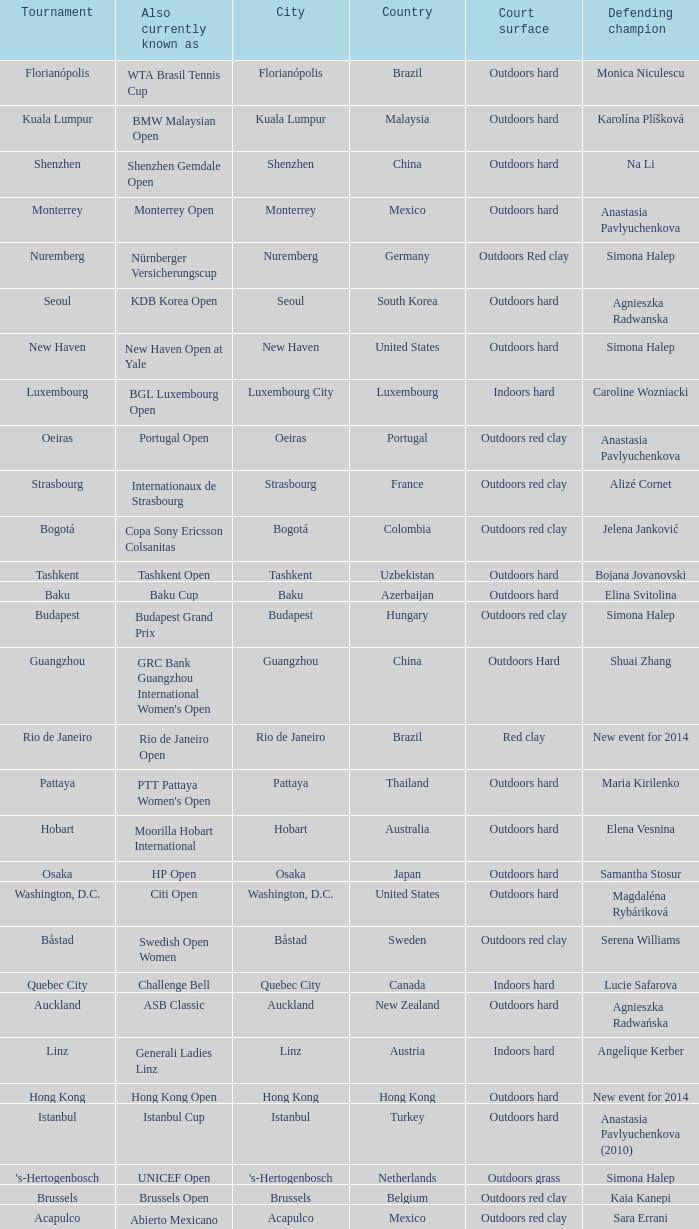What tournament is in katowice? Katowice. 